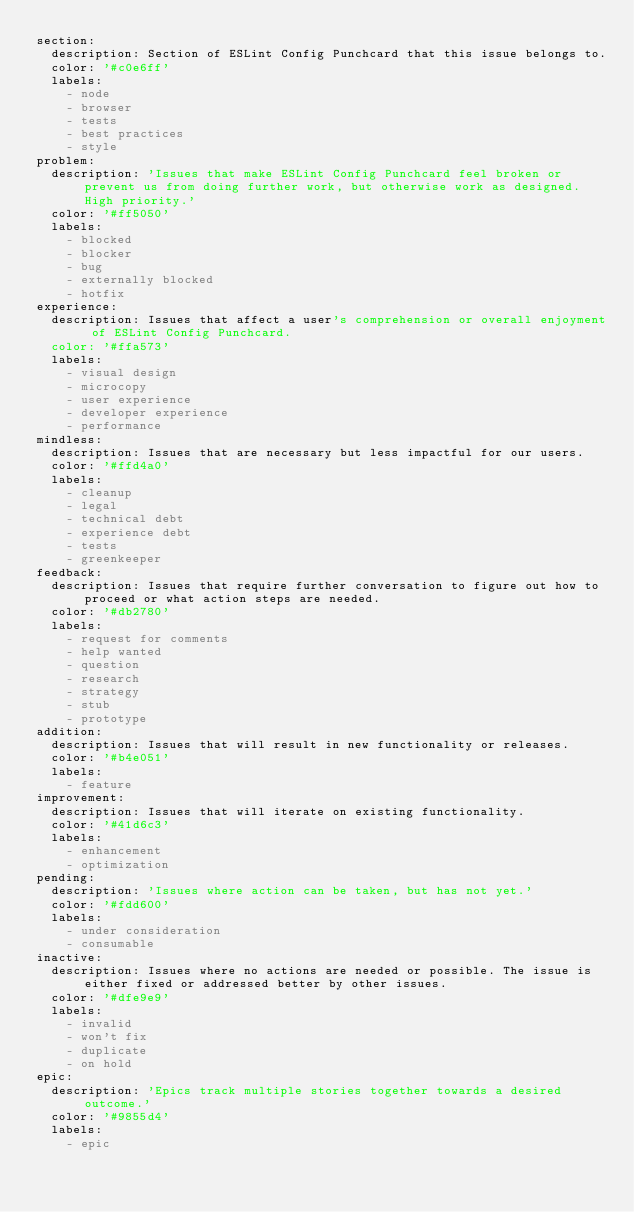<code> <loc_0><loc_0><loc_500><loc_500><_YAML_>section:
  description: Section of ESLint Config Punchcard that this issue belongs to.
  color: '#c0e6ff'
  labels:
    - node
    - browser
    - tests
    - best practices
    - style
problem:
  description: 'Issues that make ESLint Config Punchcard feel broken or prevent us from doing further work, but otherwise work as designed. High priority.'
  color: '#ff5050'
  labels:
    - blocked
    - blocker
    - bug
    - externally blocked
    - hotfix
experience:
  description: Issues that affect a user's comprehension or overall enjoyment of ESLint Config Punchcard.
  color: '#ffa573'
  labels:
    - visual design
    - microcopy
    - user experience
    - developer experience
    - performance
mindless:
  description: Issues that are necessary but less impactful for our users.
  color: '#ffd4a0'
  labels:
    - cleanup
    - legal
    - technical debt
    - experience debt
    - tests
    - greenkeeper
feedback:
  description: Issues that require further conversation to figure out how to proceed or what action steps are needed.
  color: '#db2780'
  labels:
    - request for comments
    - help wanted
    - question
    - research
    - strategy
    - stub
    - prototype
addition:
  description: Issues that will result in new functionality or releases.
  color: '#b4e051'
  labels:
    - feature
improvement:
  description: Issues that will iterate on existing functionality.
  color: '#41d6c3'
  labels:
    - enhancement
    - optimization
pending:
  description: 'Issues where action can be taken, but has not yet.'
  color: '#fdd600'
  labels:
    - under consideration
    - consumable
inactive:
  description: Issues where no actions are needed or possible. The issue is either fixed or addressed better by other issues.
  color: '#dfe9e9'
  labels:
    - invalid
    - won't fix
    - duplicate
    - on hold
epic:
  description: 'Epics track multiple stories together towards a desired outcome.'
  color: '#9855d4'
  labels:
    - epic
</code> 